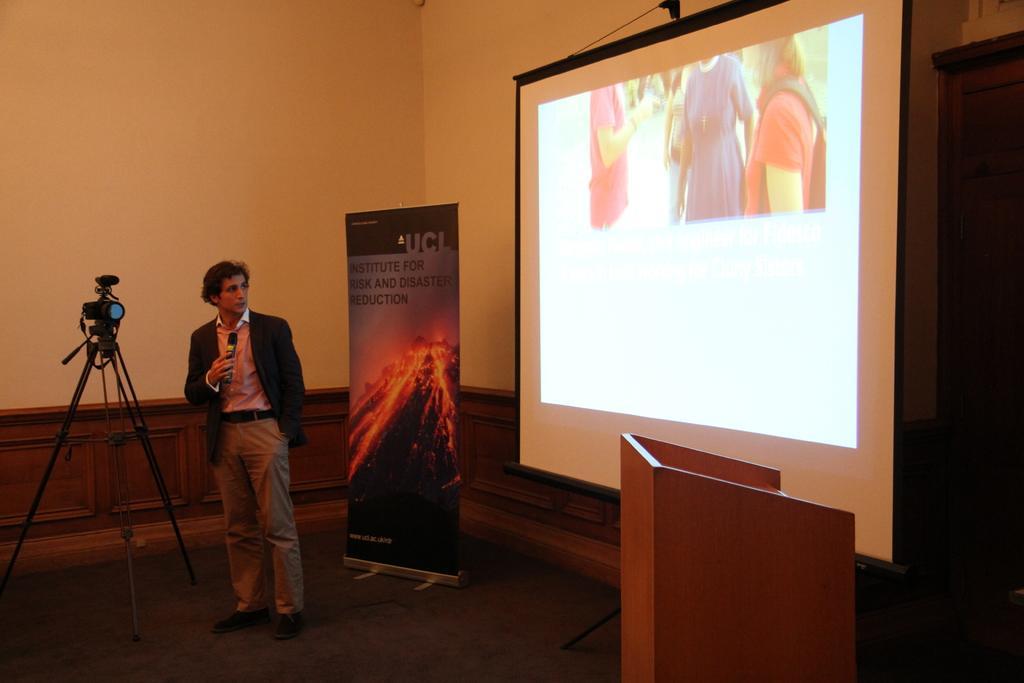Please provide a concise description of this image. In the center of the image we can see a person is standing and he is holding a microphone. On the left side of the image, there is a stand with a camera. On the right side of the image, we can see a wooden stand. In the background there is a wall, banner, screen and one wooden object. On the screen, we can see a few people. 